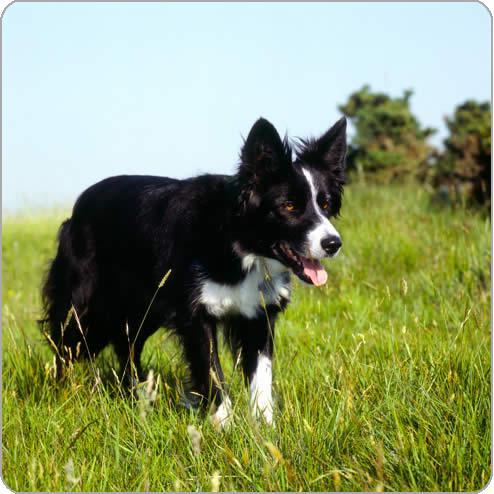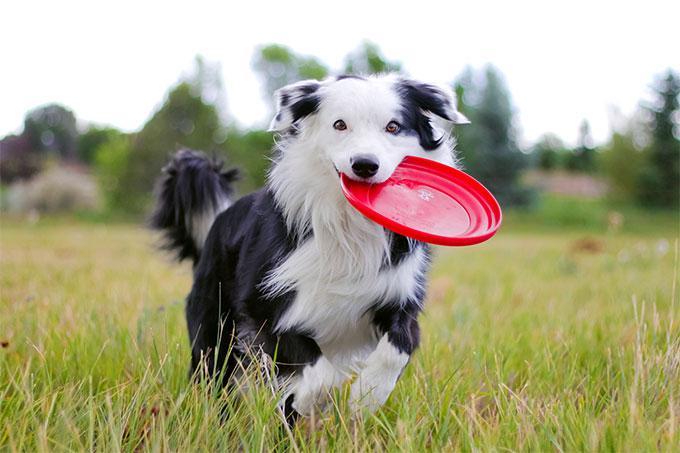The first image is the image on the left, the second image is the image on the right. Analyze the images presented: Is the assertion "There are exactly two dogs in the image on the right." valid? Answer yes or no. No. 